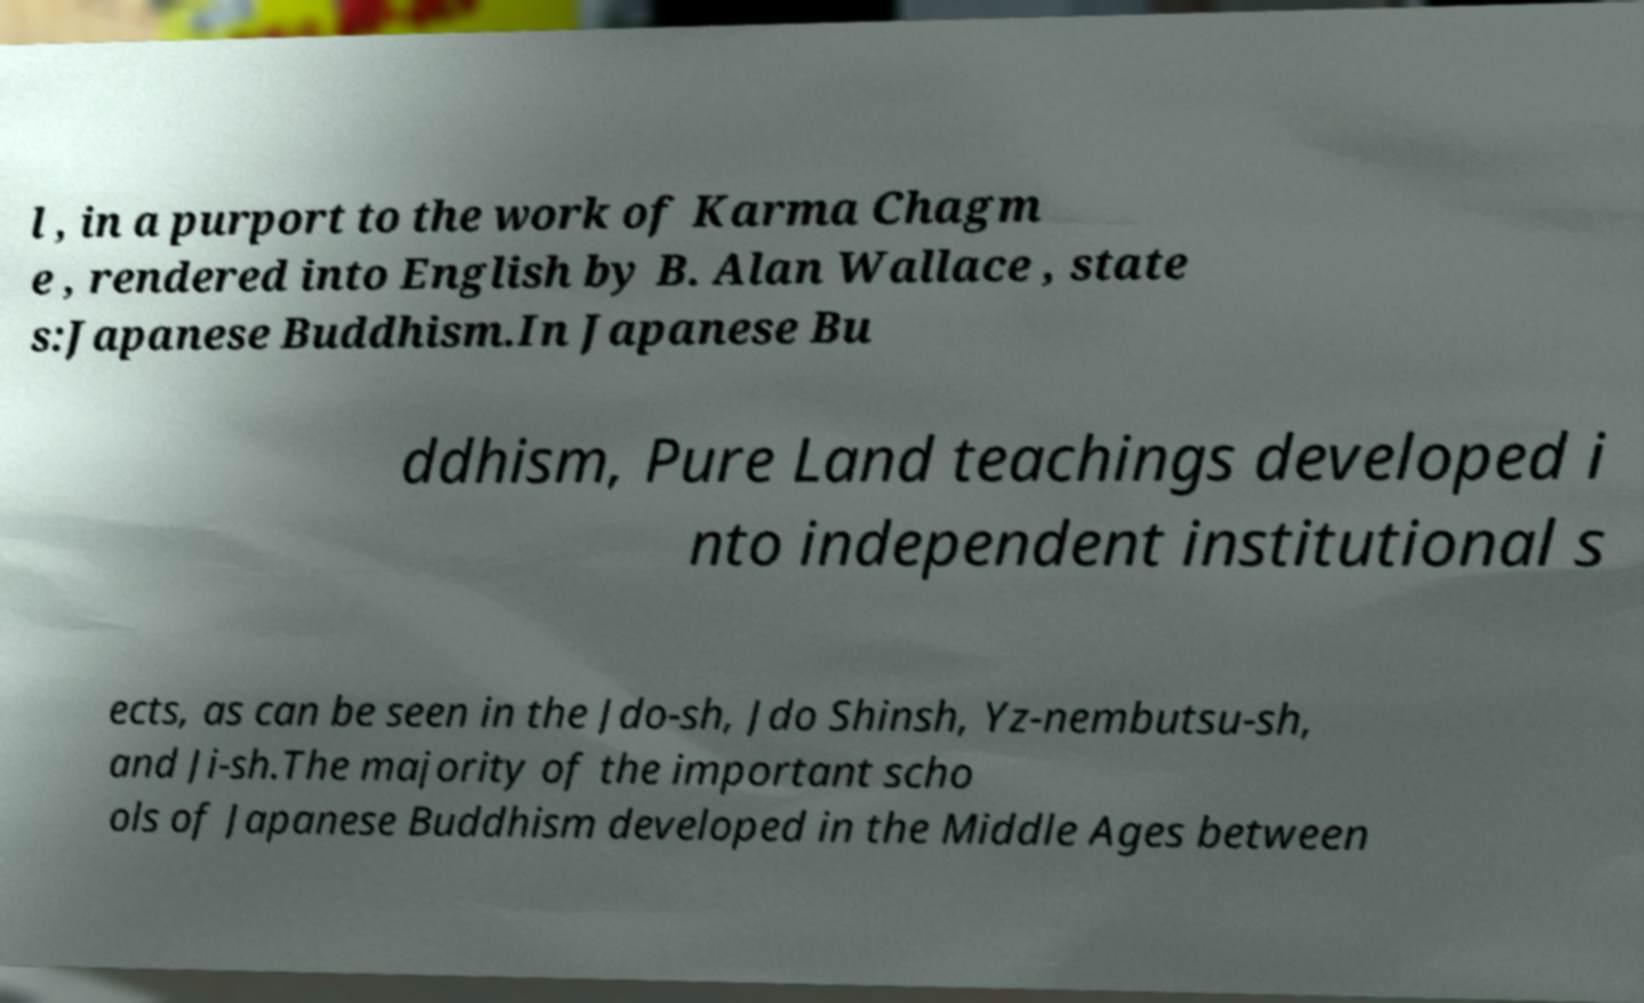There's text embedded in this image that I need extracted. Can you transcribe it verbatim? l , in a purport to the work of Karma Chagm e , rendered into English by B. Alan Wallace , state s:Japanese Buddhism.In Japanese Bu ddhism, Pure Land teachings developed i nto independent institutional s ects, as can be seen in the Jdo-sh, Jdo Shinsh, Yz-nembutsu-sh, and Ji-sh.The majority of the important scho ols of Japanese Buddhism developed in the Middle Ages between 